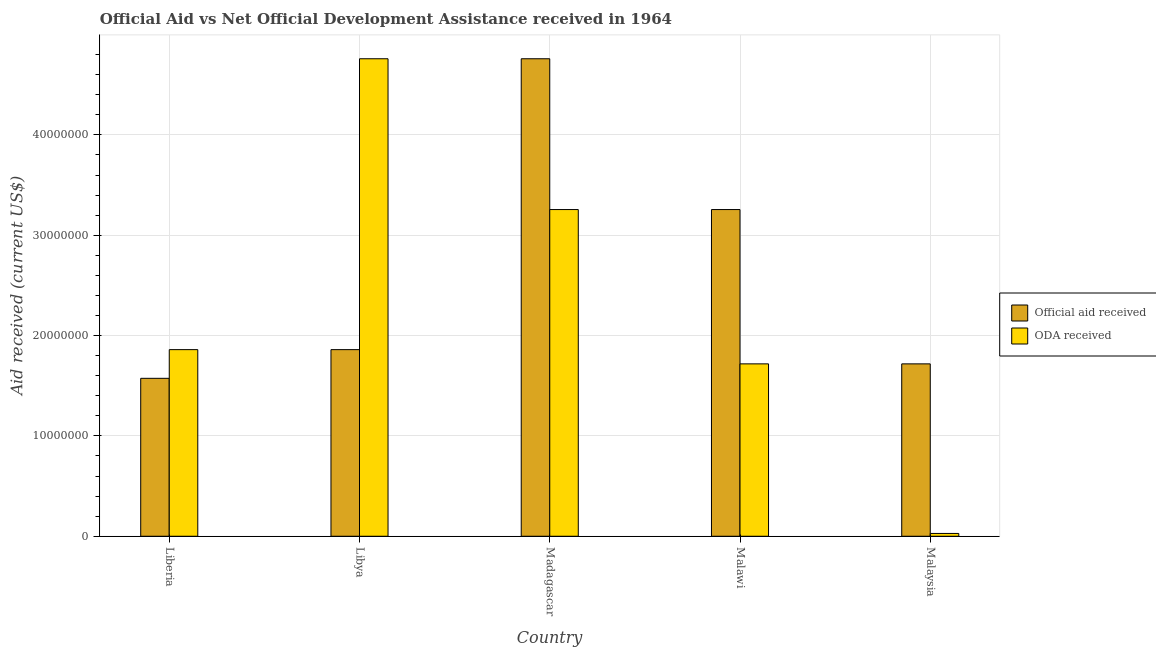How many groups of bars are there?
Keep it short and to the point. 5. Are the number of bars per tick equal to the number of legend labels?
Your answer should be very brief. Yes. How many bars are there on the 5th tick from the left?
Make the answer very short. 2. How many bars are there on the 3rd tick from the right?
Offer a terse response. 2. What is the label of the 5th group of bars from the left?
Your response must be concise. Malaysia. In how many cases, is the number of bars for a given country not equal to the number of legend labels?
Provide a short and direct response. 0. What is the oda received in Liberia?
Ensure brevity in your answer.  1.86e+07. Across all countries, what is the maximum official aid received?
Provide a short and direct response. 4.76e+07. Across all countries, what is the minimum oda received?
Offer a very short reply. 2.80e+05. In which country was the oda received maximum?
Offer a terse response. Libya. In which country was the oda received minimum?
Your answer should be compact. Malaysia. What is the total oda received in the graph?
Give a very brief answer. 1.16e+08. What is the difference between the official aid received in Malawi and that in Malaysia?
Offer a very short reply. 1.54e+07. What is the difference between the official aid received in Malaysia and the oda received in Malawi?
Provide a short and direct response. 0. What is the average oda received per country?
Your answer should be compact. 2.32e+07. What is the difference between the official aid received and oda received in Malawi?
Provide a succinct answer. 1.54e+07. What is the ratio of the official aid received in Libya to that in Malaysia?
Your response must be concise. 1.08. Is the difference between the oda received in Madagascar and Malaysia greater than the difference between the official aid received in Madagascar and Malaysia?
Make the answer very short. Yes. What is the difference between the highest and the second highest oda received?
Your answer should be very brief. 1.50e+07. What is the difference between the highest and the lowest oda received?
Provide a short and direct response. 4.73e+07. Is the sum of the oda received in Libya and Madagascar greater than the maximum official aid received across all countries?
Ensure brevity in your answer.  Yes. What does the 1st bar from the left in Madagascar represents?
Provide a short and direct response. Official aid received. What does the 1st bar from the right in Malaysia represents?
Offer a terse response. ODA received. How many countries are there in the graph?
Keep it short and to the point. 5. Does the graph contain any zero values?
Provide a succinct answer. No. Where does the legend appear in the graph?
Give a very brief answer. Center right. How many legend labels are there?
Offer a very short reply. 2. What is the title of the graph?
Make the answer very short. Official Aid vs Net Official Development Assistance received in 1964 . Does "Official aid received" appear as one of the legend labels in the graph?
Make the answer very short. Yes. What is the label or title of the X-axis?
Ensure brevity in your answer.  Country. What is the label or title of the Y-axis?
Ensure brevity in your answer.  Aid received (current US$). What is the Aid received (current US$) in Official aid received in Liberia?
Ensure brevity in your answer.  1.57e+07. What is the Aid received (current US$) of ODA received in Liberia?
Your answer should be very brief. 1.86e+07. What is the Aid received (current US$) in Official aid received in Libya?
Provide a succinct answer. 1.86e+07. What is the Aid received (current US$) in ODA received in Libya?
Provide a short and direct response. 4.76e+07. What is the Aid received (current US$) of Official aid received in Madagascar?
Ensure brevity in your answer.  4.76e+07. What is the Aid received (current US$) in ODA received in Madagascar?
Ensure brevity in your answer.  3.26e+07. What is the Aid received (current US$) in Official aid received in Malawi?
Your answer should be compact. 3.26e+07. What is the Aid received (current US$) in ODA received in Malawi?
Your response must be concise. 1.72e+07. What is the Aid received (current US$) of Official aid received in Malaysia?
Your answer should be compact. 1.72e+07. What is the Aid received (current US$) of ODA received in Malaysia?
Make the answer very short. 2.80e+05. Across all countries, what is the maximum Aid received (current US$) in Official aid received?
Your answer should be compact. 4.76e+07. Across all countries, what is the maximum Aid received (current US$) of ODA received?
Provide a short and direct response. 4.76e+07. Across all countries, what is the minimum Aid received (current US$) in Official aid received?
Ensure brevity in your answer.  1.57e+07. What is the total Aid received (current US$) in Official aid received in the graph?
Offer a terse response. 1.32e+08. What is the total Aid received (current US$) in ODA received in the graph?
Ensure brevity in your answer.  1.16e+08. What is the difference between the Aid received (current US$) of Official aid received in Liberia and that in Libya?
Offer a very short reply. -2.86e+06. What is the difference between the Aid received (current US$) of ODA received in Liberia and that in Libya?
Ensure brevity in your answer.  -2.90e+07. What is the difference between the Aid received (current US$) in Official aid received in Liberia and that in Madagascar?
Keep it short and to the point. -3.18e+07. What is the difference between the Aid received (current US$) in ODA received in Liberia and that in Madagascar?
Keep it short and to the point. -1.40e+07. What is the difference between the Aid received (current US$) of Official aid received in Liberia and that in Malawi?
Your answer should be compact. -1.68e+07. What is the difference between the Aid received (current US$) in ODA received in Liberia and that in Malawi?
Offer a very short reply. 1.42e+06. What is the difference between the Aid received (current US$) in Official aid received in Liberia and that in Malaysia?
Ensure brevity in your answer.  -1.44e+06. What is the difference between the Aid received (current US$) of ODA received in Liberia and that in Malaysia?
Your answer should be compact. 1.83e+07. What is the difference between the Aid received (current US$) of Official aid received in Libya and that in Madagascar?
Ensure brevity in your answer.  -2.90e+07. What is the difference between the Aid received (current US$) in ODA received in Libya and that in Madagascar?
Ensure brevity in your answer.  1.50e+07. What is the difference between the Aid received (current US$) of Official aid received in Libya and that in Malawi?
Make the answer very short. -1.40e+07. What is the difference between the Aid received (current US$) of ODA received in Libya and that in Malawi?
Offer a very short reply. 3.04e+07. What is the difference between the Aid received (current US$) in Official aid received in Libya and that in Malaysia?
Provide a short and direct response. 1.42e+06. What is the difference between the Aid received (current US$) in ODA received in Libya and that in Malaysia?
Keep it short and to the point. 4.73e+07. What is the difference between the Aid received (current US$) in Official aid received in Madagascar and that in Malawi?
Ensure brevity in your answer.  1.50e+07. What is the difference between the Aid received (current US$) of ODA received in Madagascar and that in Malawi?
Provide a short and direct response. 1.54e+07. What is the difference between the Aid received (current US$) of Official aid received in Madagascar and that in Malaysia?
Give a very brief answer. 3.04e+07. What is the difference between the Aid received (current US$) of ODA received in Madagascar and that in Malaysia?
Keep it short and to the point. 3.23e+07. What is the difference between the Aid received (current US$) in Official aid received in Malawi and that in Malaysia?
Give a very brief answer. 1.54e+07. What is the difference between the Aid received (current US$) in ODA received in Malawi and that in Malaysia?
Ensure brevity in your answer.  1.69e+07. What is the difference between the Aid received (current US$) of Official aid received in Liberia and the Aid received (current US$) of ODA received in Libya?
Your response must be concise. -3.18e+07. What is the difference between the Aid received (current US$) of Official aid received in Liberia and the Aid received (current US$) of ODA received in Madagascar?
Provide a short and direct response. -1.68e+07. What is the difference between the Aid received (current US$) in Official aid received in Liberia and the Aid received (current US$) in ODA received in Malawi?
Provide a short and direct response. -1.44e+06. What is the difference between the Aid received (current US$) of Official aid received in Liberia and the Aid received (current US$) of ODA received in Malaysia?
Your answer should be compact. 1.55e+07. What is the difference between the Aid received (current US$) of Official aid received in Libya and the Aid received (current US$) of ODA received in Madagascar?
Keep it short and to the point. -1.40e+07. What is the difference between the Aid received (current US$) of Official aid received in Libya and the Aid received (current US$) of ODA received in Malawi?
Make the answer very short. 1.42e+06. What is the difference between the Aid received (current US$) in Official aid received in Libya and the Aid received (current US$) in ODA received in Malaysia?
Make the answer very short. 1.83e+07. What is the difference between the Aid received (current US$) in Official aid received in Madagascar and the Aid received (current US$) in ODA received in Malawi?
Provide a succinct answer. 3.04e+07. What is the difference between the Aid received (current US$) of Official aid received in Madagascar and the Aid received (current US$) of ODA received in Malaysia?
Offer a terse response. 4.73e+07. What is the difference between the Aid received (current US$) in Official aid received in Malawi and the Aid received (current US$) in ODA received in Malaysia?
Your answer should be compact. 3.23e+07. What is the average Aid received (current US$) of Official aid received per country?
Your answer should be very brief. 2.63e+07. What is the average Aid received (current US$) in ODA received per country?
Give a very brief answer. 2.32e+07. What is the difference between the Aid received (current US$) of Official aid received and Aid received (current US$) of ODA received in Liberia?
Keep it short and to the point. -2.86e+06. What is the difference between the Aid received (current US$) of Official aid received and Aid received (current US$) of ODA received in Libya?
Your response must be concise. -2.90e+07. What is the difference between the Aid received (current US$) in Official aid received and Aid received (current US$) in ODA received in Madagascar?
Keep it short and to the point. 1.50e+07. What is the difference between the Aid received (current US$) in Official aid received and Aid received (current US$) in ODA received in Malawi?
Make the answer very short. 1.54e+07. What is the difference between the Aid received (current US$) of Official aid received and Aid received (current US$) of ODA received in Malaysia?
Offer a very short reply. 1.69e+07. What is the ratio of the Aid received (current US$) of Official aid received in Liberia to that in Libya?
Give a very brief answer. 0.85. What is the ratio of the Aid received (current US$) of ODA received in Liberia to that in Libya?
Provide a succinct answer. 0.39. What is the ratio of the Aid received (current US$) of Official aid received in Liberia to that in Madagascar?
Ensure brevity in your answer.  0.33. What is the ratio of the Aid received (current US$) in ODA received in Liberia to that in Madagascar?
Your answer should be very brief. 0.57. What is the ratio of the Aid received (current US$) in Official aid received in Liberia to that in Malawi?
Your answer should be very brief. 0.48. What is the ratio of the Aid received (current US$) in ODA received in Liberia to that in Malawi?
Provide a succinct answer. 1.08. What is the ratio of the Aid received (current US$) in Official aid received in Liberia to that in Malaysia?
Provide a short and direct response. 0.92. What is the ratio of the Aid received (current US$) of ODA received in Liberia to that in Malaysia?
Your answer should be compact. 66.43. What is the ratio of the Aid received (current US$) of Official aid received in Libya to that in Madagascar?
Your answer should be very brief. 0.39. What is the ratio of the Aid received (current US$) of ODA received in Libya to that in Madagascar?
Provide a succinct answer. 1.46. What is the ratio of the Aid received (current US$) in Official aid received in Libya to that in Malawi?
Ensure brevity in your answer.  0.57. What is the ratio of the Aid received (current US$) of ODA received in Libya to that in Malawi?
Ensure brevity in your answer.  2.77. What is the ratio of the Aid received (current US$) of Official aid received in Libya to that in Malaysia?
Your answer should be very brief. 1.08. What is the ratio of the Aid received (current US$) in ODA received in Libya to that in Malaysia?
Your answer should be very brief. 169.96. What is the ratio of the Aid received (current US$) in Official aid received in Madagascar to that in Malawi?
Your response must be concise. 1.46. What is the ratio of the Aid received (current US$) of ODA received in Madagascar to that in Malawi?
Make the answer very short. 1.9. What is the ratio of the Aid received (current US$) of Official aid received in Madagascar to that in Malaysia?
Keep it short and to the point. 2.77. What is the ratio of the Aid received (current US$) of ODA received in Madagascar to that in Malaysia?
Give a very brief answer. 116.29. What is the ratio of the Aid received (current US$) of Official aid received in Malawi to that in Malaysia?
Your answer should be compact. 1.9. What is the ratio of the Aid received (current US$) in ODA received in Malawi to that in Malaysia?
Make the answer very short. 61.36. What is the difference between the highest and the second highest Aid received (current US$) of Official aid received?
Your answer should be compact. 1.50e+07. What is the difference between the highest and the second highest Aid received (current US$) of ODA received?
Ensure brevity in your answer.  1.50e+07. What is the difference between the highest and the lowest Aid received (current US$) of Official aid received?
Ensure brevity in your answer.  3.18e+07. What is the difference between the highest and the lowest Aid received (current US$) in ODA received?
Offer a terse response. 4.73e+07. 